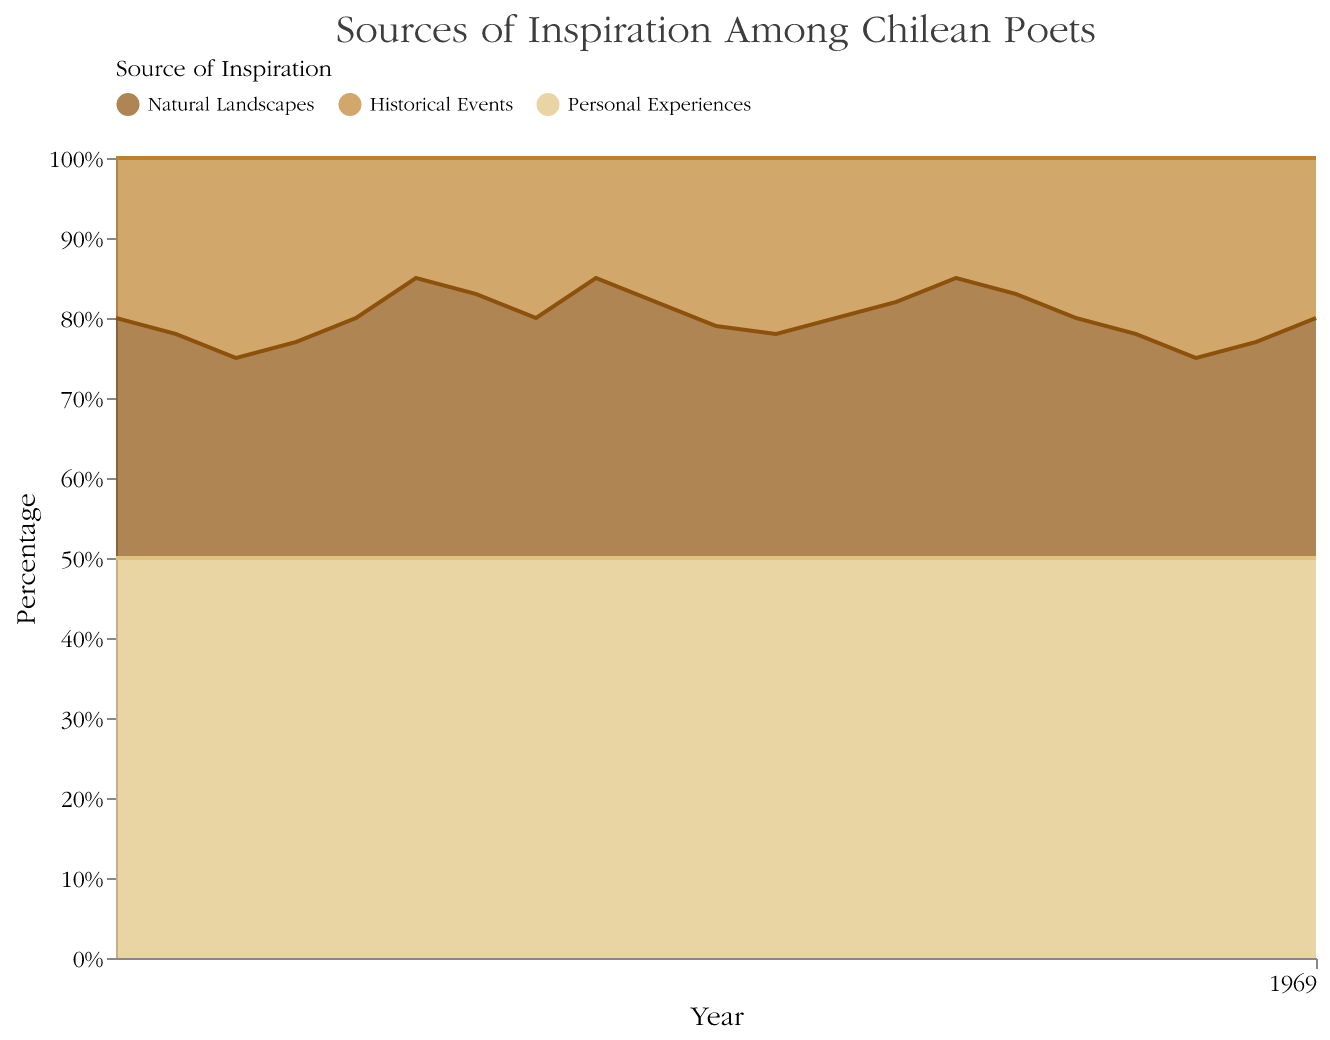What is the percentage range for personal experiences as a source of inspiration over the years? The percentage of personal experiences as a source of inspiration is constant at 50% for every year from 2000 to 2020, as indicated by the uniform area at the top of the chart.
Answer: 50% Which source of inspiration has the most significant variation throughout the years? To determine the source with the most variation, compare the fluctuation range of each category. Natural landscapes show the greatest variation, ranging from 25% to 35%. Historical events exhibit less variation, ranging from 15% to 25%.
Answer: Natural Landscapes In which years does the percentage of inspiration from historical events show a sharp increase or decrease? Refer to the transitions between years and look for significant changes in the percentage area of historical events. Sharp changes are seen from 2002 to 2003 (increase from 20% to 25%) and from 2005 to 2006 (decrease from 15% to 17%)
Answer: 2002-2003, 2005-2006 Which category consistently remains at a stable percentage throughout the years? Review the stacked areas in the chart and observe which category remains unchanged. Personal experiences stay at a stable 50% throughout all the represented years.
Answer: Personal Experiences Was there any year where the inspiration from natural landscapes and historical events were equal? Compare the percentage heights of the two areas for each year. In the year 2002, both natural landscapes and historical events were at 25%.
Answer: 2002 How does the percentage of inspiration from natural landscapes change from 2000 to 2020? Trace the trend line for natural landscapes from 2000 to 2020. It starts at 30% in 2000 to 30% again in 2020, but with fluctuations in between, hitting as high as 35% and as low as 25%.
Answer: Starts at 30%, fluctuates, and ends at 30% Comparing the years 2005 and 2014, what can you say about the shift in sources of inspiration? Look at the percentages for each source in those two years. Both years show an identical pattern: Personal experiences at 50%, natural landscapes at 35%, and historical events at 15%.
Answer: No shift; identical patterns Which year shows the highest percentage of natural landscapes as an inspiration, and what is that percentage? Identify the highest point of the natural landscapes area over the years. Both 2005, 2008, and 2014 show 35%, the highest across the dataset.
Answer: 2005, 2008, 2014; 35% How did the sources of inspiration from historical events differ between 2010 and 2019? Compare the segments of historical events in these two years. In 2010, historical events were at 21%, whereas in 2019, they were at 23%.
Answer: 21% in 2010, 23% in 2019 What was the trend for personal experiences as a source of inspiration from 2000 to 2020? Check the percentage color area representing personal experiences for a trend pattern; it remains constant at 50% every year.
Answer: Constant 50% 